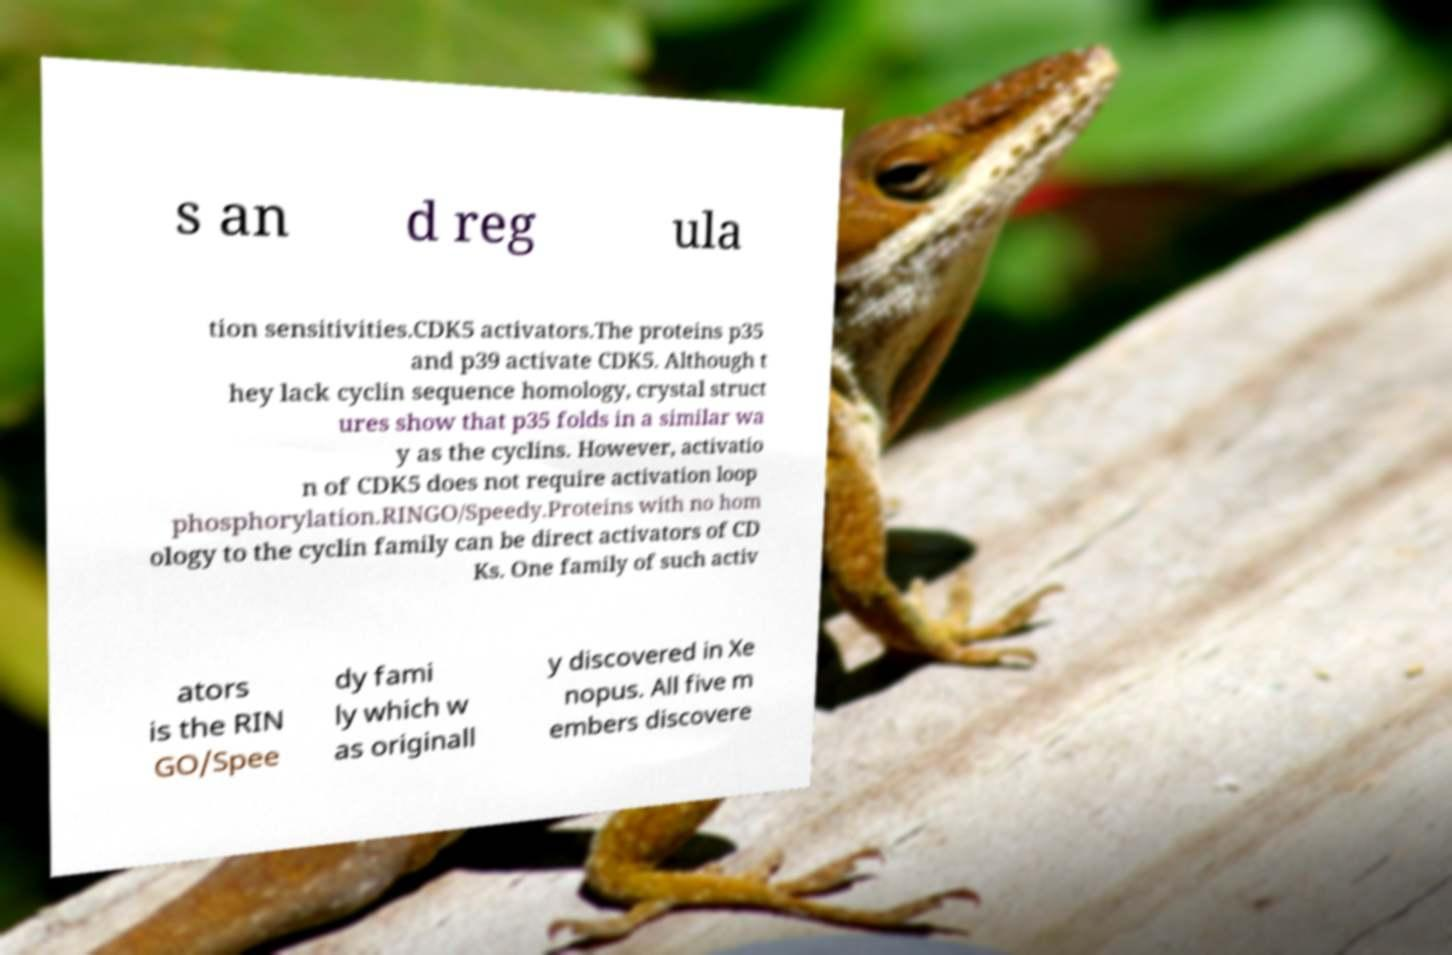Could you assist in decoding the text presented in this image and type it out clearly? s an d reg ula tion sensitivities.CDK5 activators.The proteins p35 and p39 activate CDK5. Although t hey lack cyclin sequence homology, crystal struct ures show that p35 folds in a similar wa y as the cyclins. However, activatio n of CDK5 does not require activation loop phosphorylation.RINGO/Speedy.Proteins with no hom ology to the cyclin family can be direct activators of CD Ks. One family of such activ ators is the RIN GO/Spee dy fami ly which w as originall y discovered in Xe nopus. All five m embers discovere 